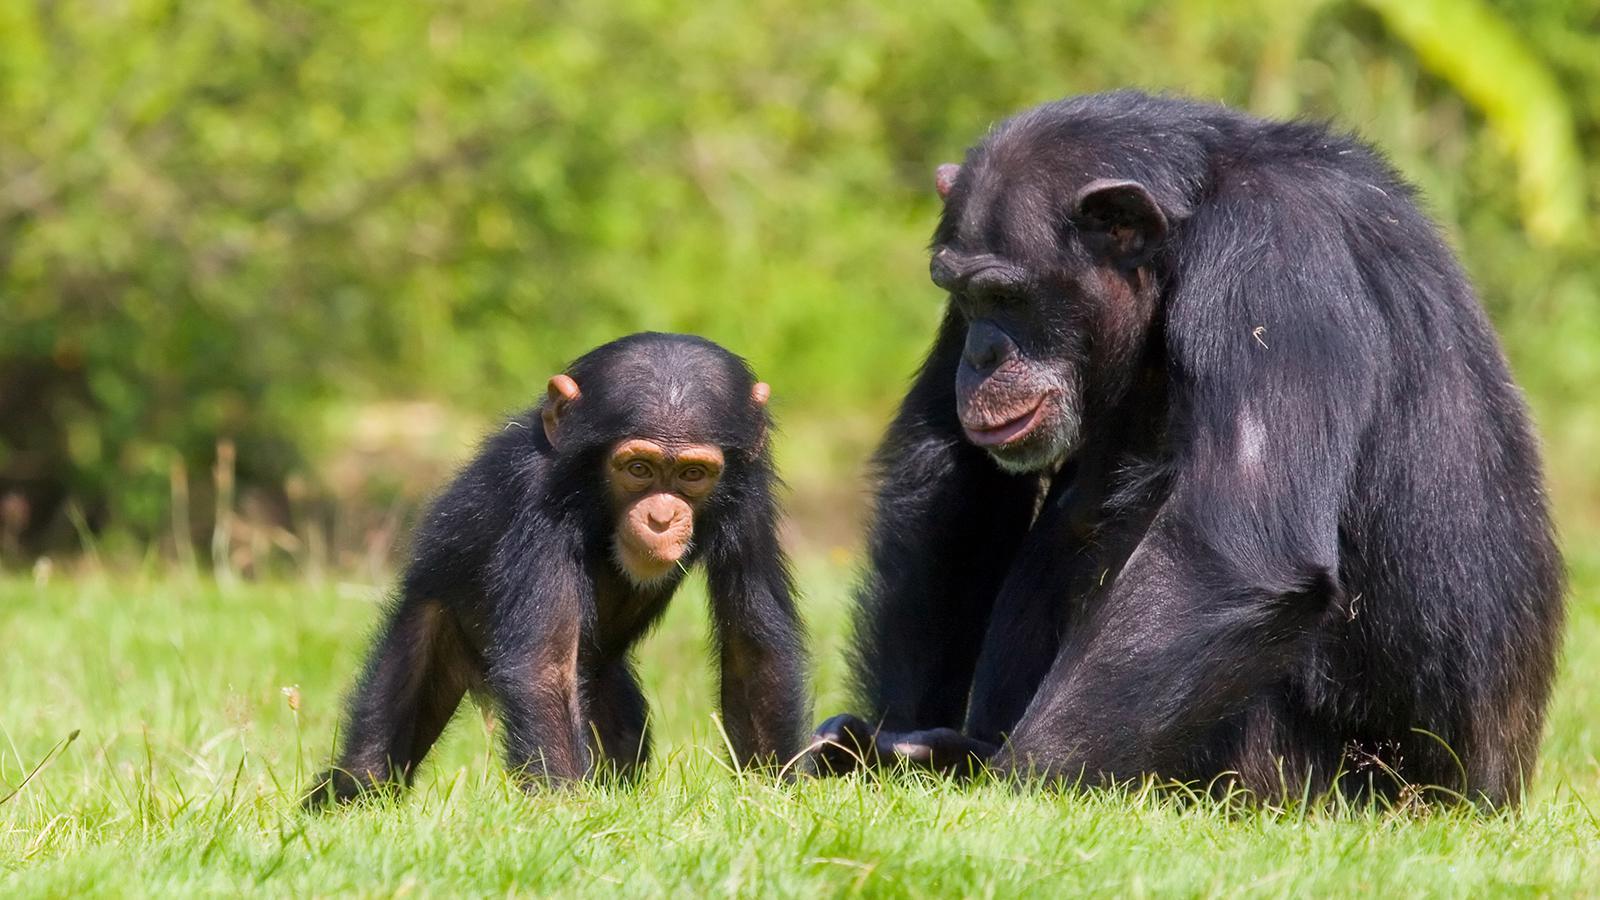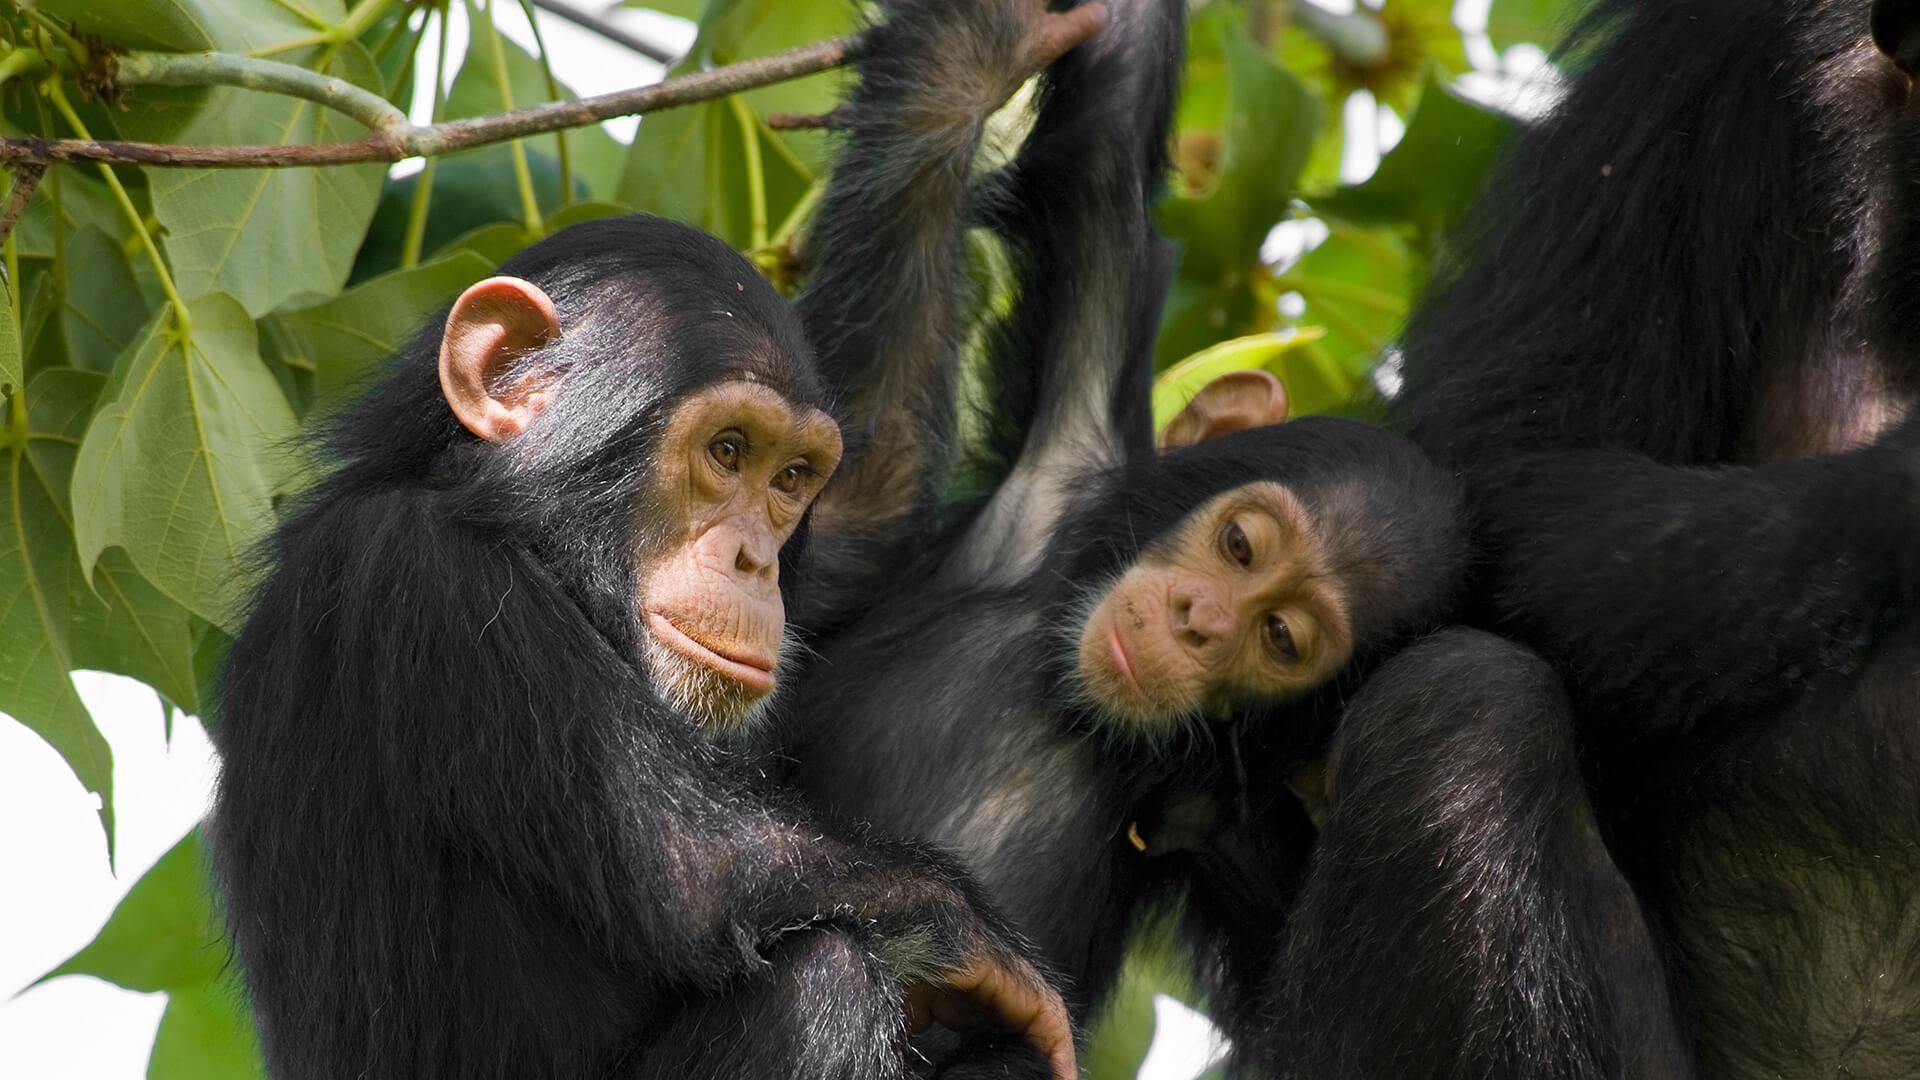The first image is the image on the left, the second image is the image on the right. Considering the images on both sides, is "The left image contains more chimps than the right image." valid? Answer yes or no. No. 